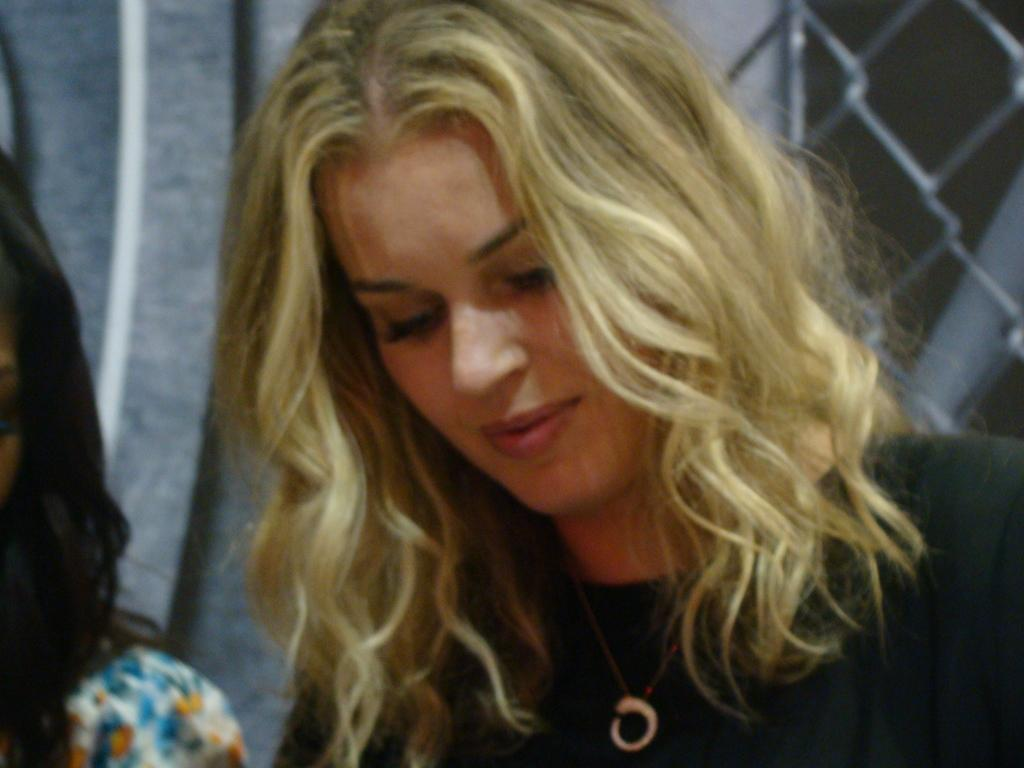How many people are in the image? There are two women in the image. What can be seen in the background of the image? There is a mesh in the background of the image. What might be a functional item on the left side of the image? It appears to be a curtain on the left side of the image. What type of cabbage is being thrown away in the image? There is no cabbage or waste present in the image. Is there any sleet visible in the image? There is no sleet visible in the image. 